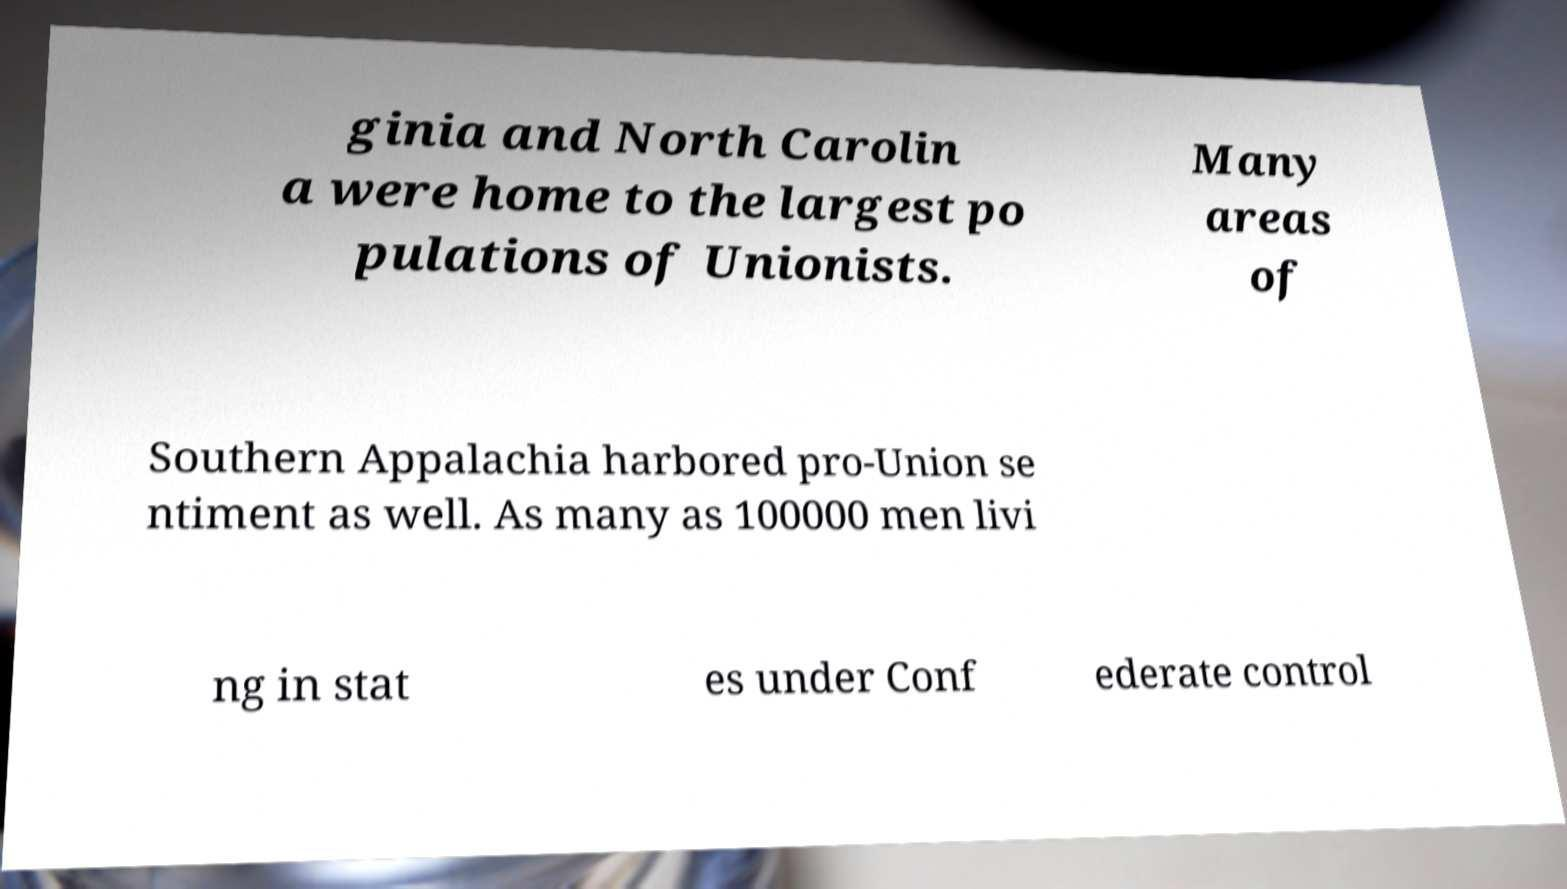Could you extract and type out the text from this image? ginia and North Carolin a were home to the largest po pulations of Unionists. Many areas of Southern Appalachia harbored pro-Union se ntiment as well. As many as 100000 men livi ng in stat es under Conf ederate control 